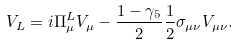Convert formula to latex. <formula><loc_0><loc_0><loc_500><loc_500>V _ { L } = i \Pi _ { \mu } ^ { L } V _ { \mu } - \frac { 1 - \gamma _ { 5 } } { 2 } \frac { 1 } { 2 } \sigma _ { \mu \nu } V _ { \mu \nu } .</formula> 